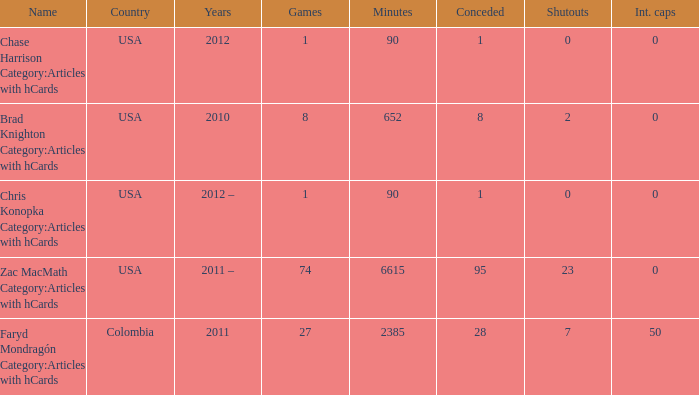When 2010 is the year what is the game? 8.0. 